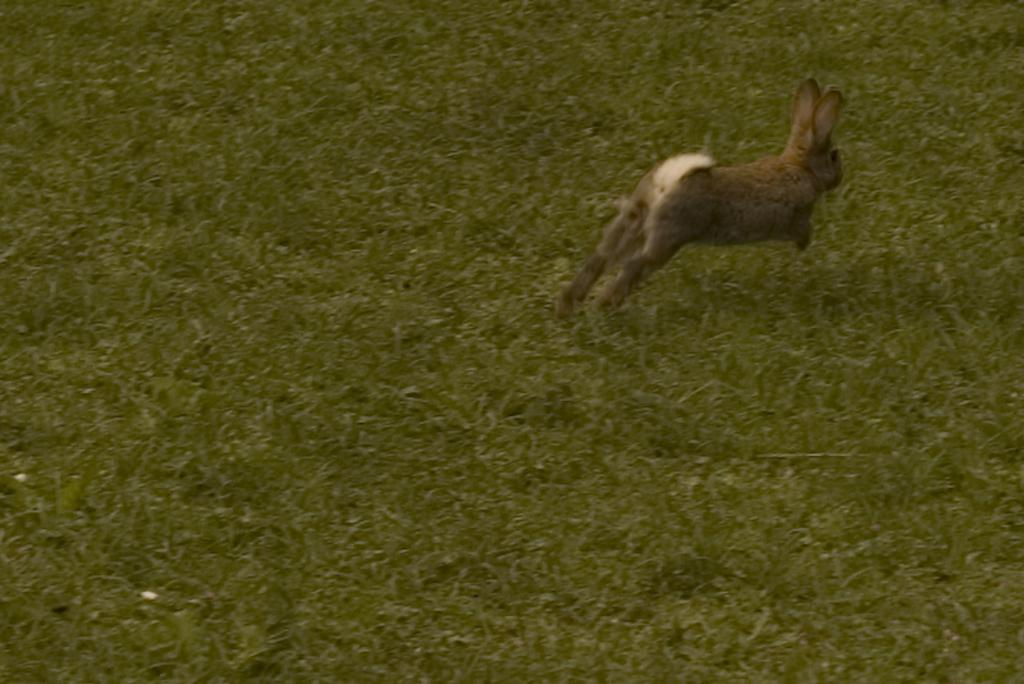What type of animal is present in the image? There is a rabbit in the image. What type of vegetation can be seen in the image? There is grass in the image. What type of pets are visible on the island in the image? There is no island or pets present in the image; it features a rabbit and grass. What type of skirt is the rabbit wearing in the image? Rabbits do not wear clothing, so there is no skirt present in the image. 